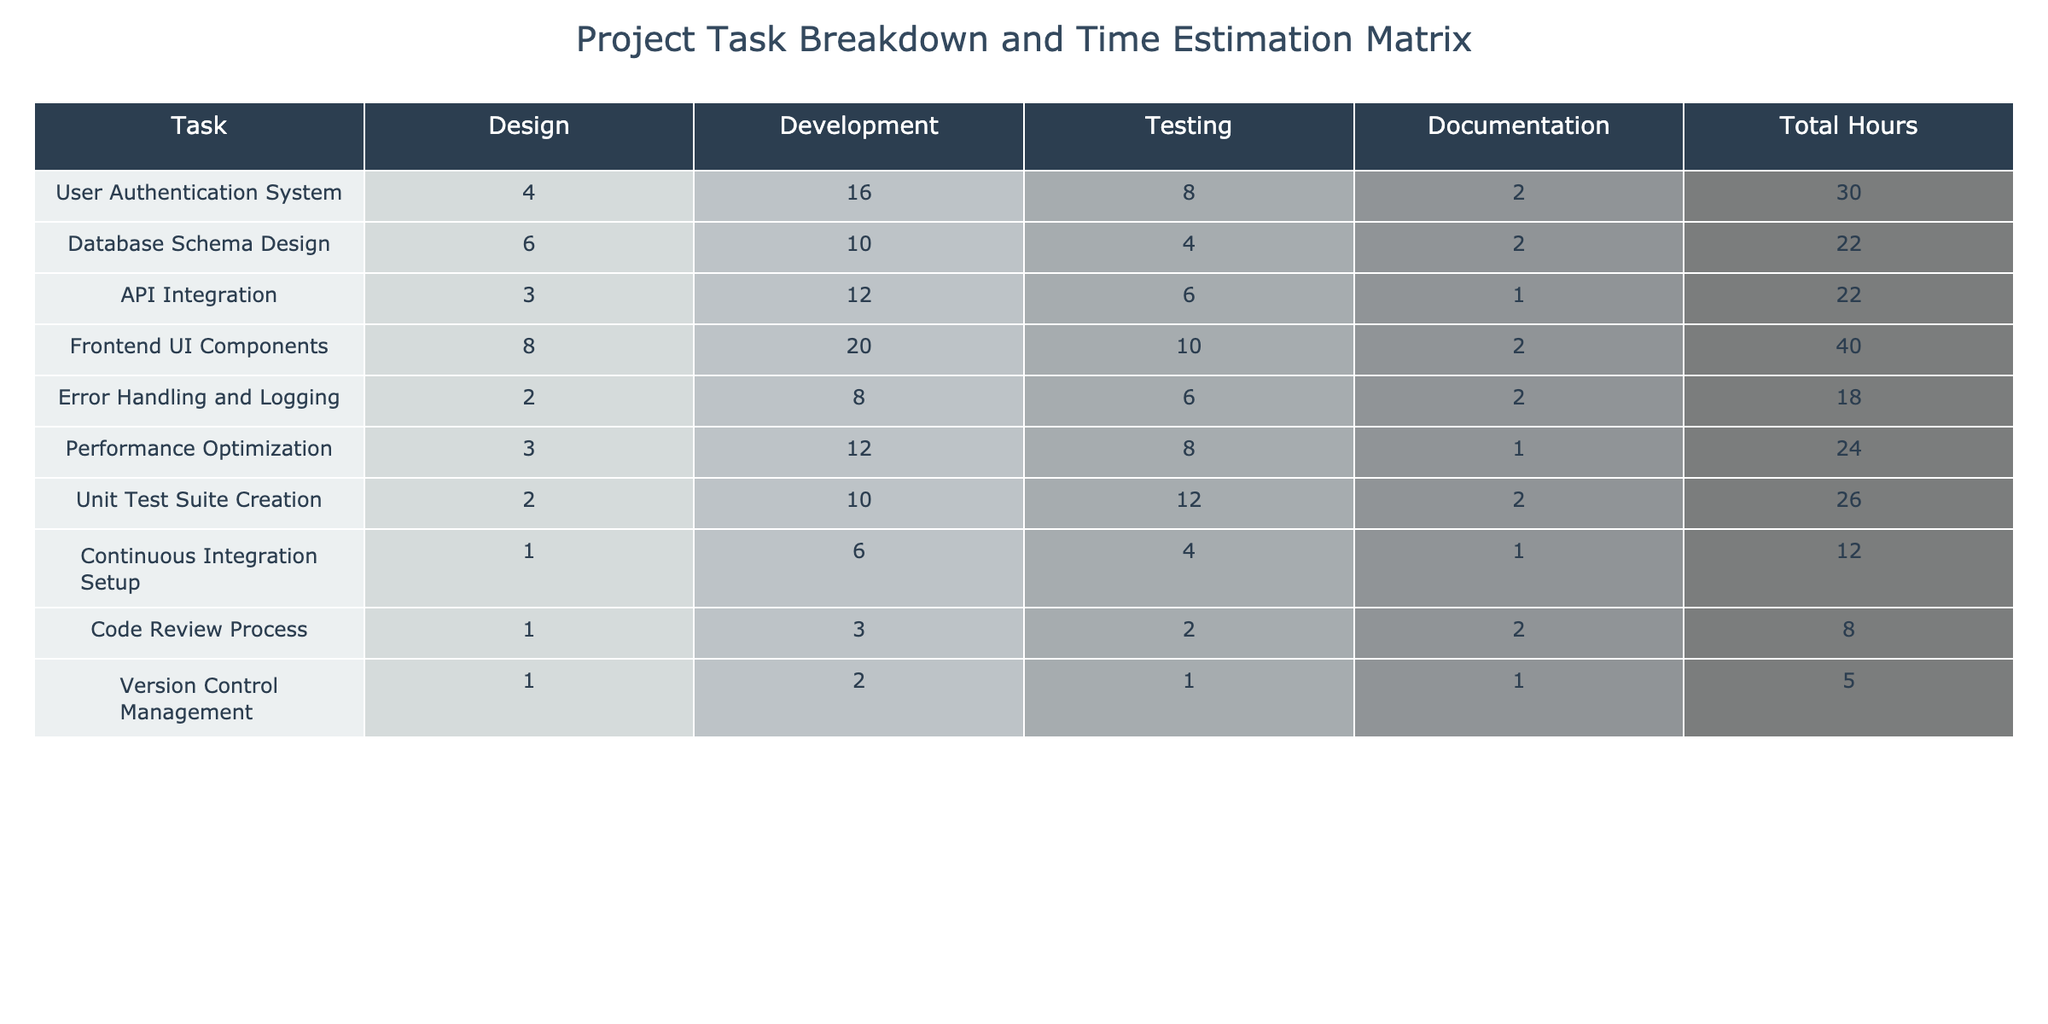What is the total estimated time for the User Authentication System task? The total estimated time for the User Authentication System task is listed directly in the table under the Total Hours column, which shows 30 hours for this task.
Answer: 30 hours Which task requires the most hours for Development? Looking at the Development column, the task that has the highest value is Frontend UI Components with 20 hours.
Answer: Frontend UI Components How many hours are allocated to Testing for the Database Schema Design? The Testing hours for Database Schema Design can be directly found in the Testing column, which shows 4 hours allocated for this task.
Answer: 4 hours Is the total time for API Integration more than 25 hours? The total estimated time for API Integration is 22 hours, which is less than 25 hours, so the statement is false.
Answer: No What is the average total hours of all tasks listed in the table? To find the average, sum all the total hours (30 + 22 + 22 + 40 + 18 + 24 + 26 + 12 + 8 + 5 =  207) and divide by the number of tasks (10). So the average is 207 / 10 = 20.7 hours.
Answer: 20.7 hours How many tasks have a total estimate of more than 25 hours? The tasks with total estimates over 25 hours are: User Authentication System (30 hours), Frontend UI Components (40 hours), Unit Test Suite Creation (26 hours), and Performance Optimization (24 hours). That's a total of 4 tasks exceeding 25 hours.
Answer: 4 tasks What is the difference in total hours between the task with the maximum total and the task with the minimum total? The task with the maximum total hours is Frontend UI Components (40 hours), and the task with the minimum total is Version Control Management (5 hours). The difference is calculated as 40 - 5 = 35 hours.
Answer: 35 hours Which task has the highest number of hours for Documentation? The task with the highest hours allocated for Documentation can be found in the Documentation column, which is Unit Test Suite Creation with 2 hours.
Answer: Unit Test Suite Creation If we combine the Development hours of the User Authentication System and the Database Schema Design, how many hours does that total? To find this, add the Development hours of both tasks: User Authentication System has 16 hours and Database Schema Design has 10 hours. So, 16 + 10 = 26 hours.
Answer: 26 hours Is it true that the Error Handling and Logging task has a higher total than Performance Optimization? Comparing the total hours, Error Handling and Logging has 18 hours and Performance Optimization has 24 hours. Since 18 is less than 24, the statement is false.
Answer: No 